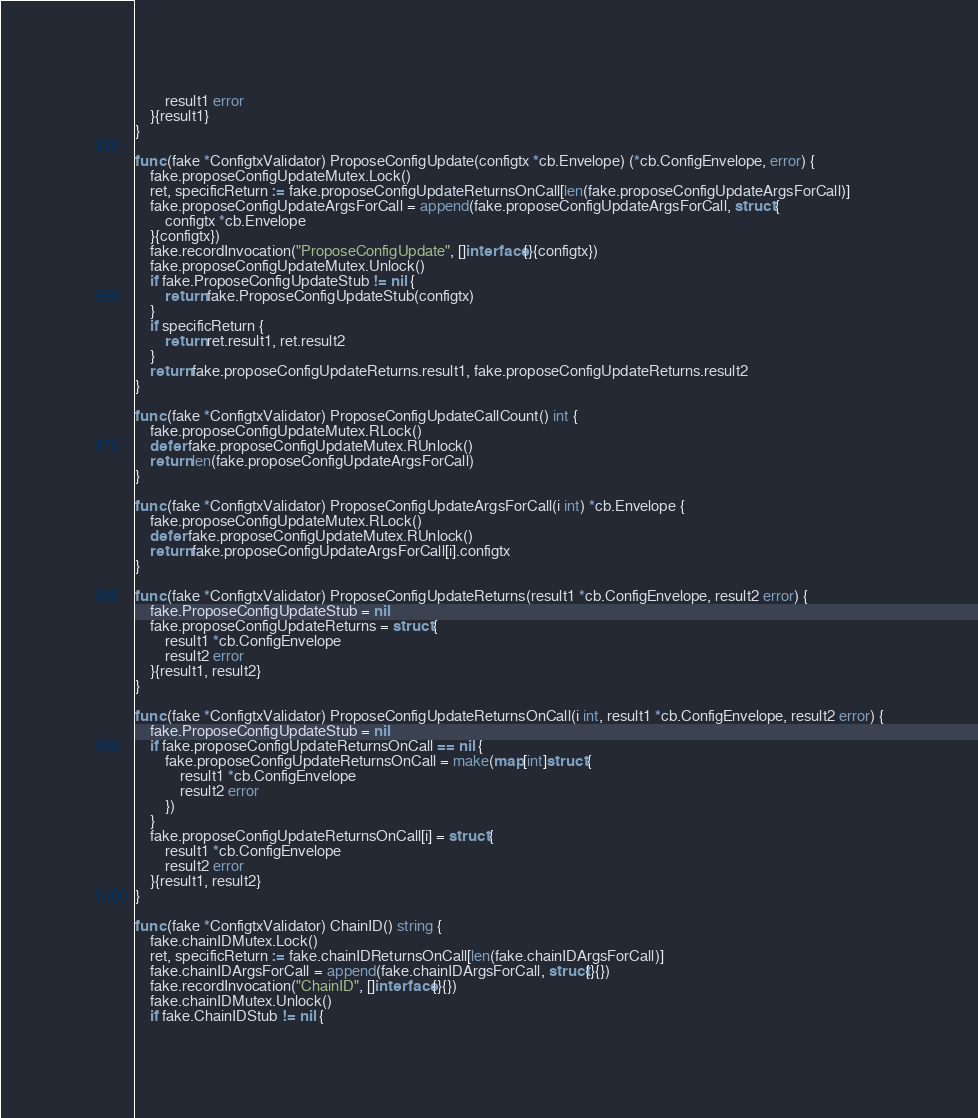<code> <loc_0><loc_0><loc_500><loc_500><_Go_>		result1 error
	}{result1}
}

func (fake *ConfigtxValidator) ProposeConfigUpdate(configtx *cb.Envelope) (*cb.ConfigEnvelope, error) {
	fake.proposeConfigUpdateMutex.Lock()
	ret, specificReturn := fake.proposeConfigUpdateReturnsOnCall[len(fake.proposeConfigUpdateArgsForCall)]
	fake.proposeConfigUpdateArgsForCall = append(fake.proposeConfigUpdateArgsForCall, struct {
		configtx *cb.Envelope
	}{configtx})
	fake.recordInvocation("ProposeConfigUpdate", []interface{}{configtx})
	fake.proposeConfigUpdateMutex.Unlock()
	if fake.ProposeConfigUpdateStub != nil {
		return fake.ProposeConfigUpdateStub(configtx)
	}
	if specificReturn {
		return ret.result1, ret.result2
	}
	return fake.proposeConfigUpdateReturns.result1, fake.proposeConfigUpdateReturns.result2
}

func (fake *ConfigtxValidator) ProposeConfigUpdateCallCount() int {
	fake.proposeConfigUpdateMutex.RLock()
	defer fake.proposeConfigUpdateMutex.RUnlock()
	return len(fake.proposeConfigUpdateArgsForCall)
}

func (fake *ConfigtxValidator) ProposeConfigUpdateArgsForCall(i int) *cb.Envelope {
	fake.proposeConfigUpdateMutex.RLock()
	defer fake.proposeConfigUpdateMutex.RUnlock()
	return fake.proposeConfigUpdateArgsForCall[i].configtx
}

func (fake *ConfigtxValidator) ProposeConfigUpdateReturns(result1 *cb.ConfigEnvelope, result2 error) {
	fake.ProposeConfigUpdateStub = nil
	fake.proposeConfigUpdateReturns = struct {
		result1 *cb.ConfigEnvelope
		result2 error
	}{result1, result2}
}

func (fake *ConfigtxValidator) ProposeConfigUpdateReturnsOnCall(i int, result1 *cb.ConfigEnvelope, result2 error) {
	fake.ProposeConfigUpdateStub = nil
	if fake.proposeConfigUpdateReturnsOnCall == nil {
		fake.proposeConfigUpdateReturnsOnCall = make(map[int]struct {
			result1 *cb.ConfigEnvelope
			result2 error
		})
	}
	fake.proposeConfigUpdateReturnsOnCall[i] = struct {
		result1 *cb.ConfigEnvelope
		result2 error
	}{result1, result2}
}

func (fake *ConfigtxValidator) ChainID() string {
	fake.chainIDMutex.Lock()
	ret, specificReturn := fake.chainIDReturnsOnCall[len(fake.chainIDArgsForCall)]
	fake.chainIDArgsForCall = append(fake.chainIDArgsForCall, struct{}{})
	fake.recordInvocation("ChainID", []interface{}{})
	fake.chainIDMutex.Unlock()
	if fake.ChainIDStub != nil {</code> 